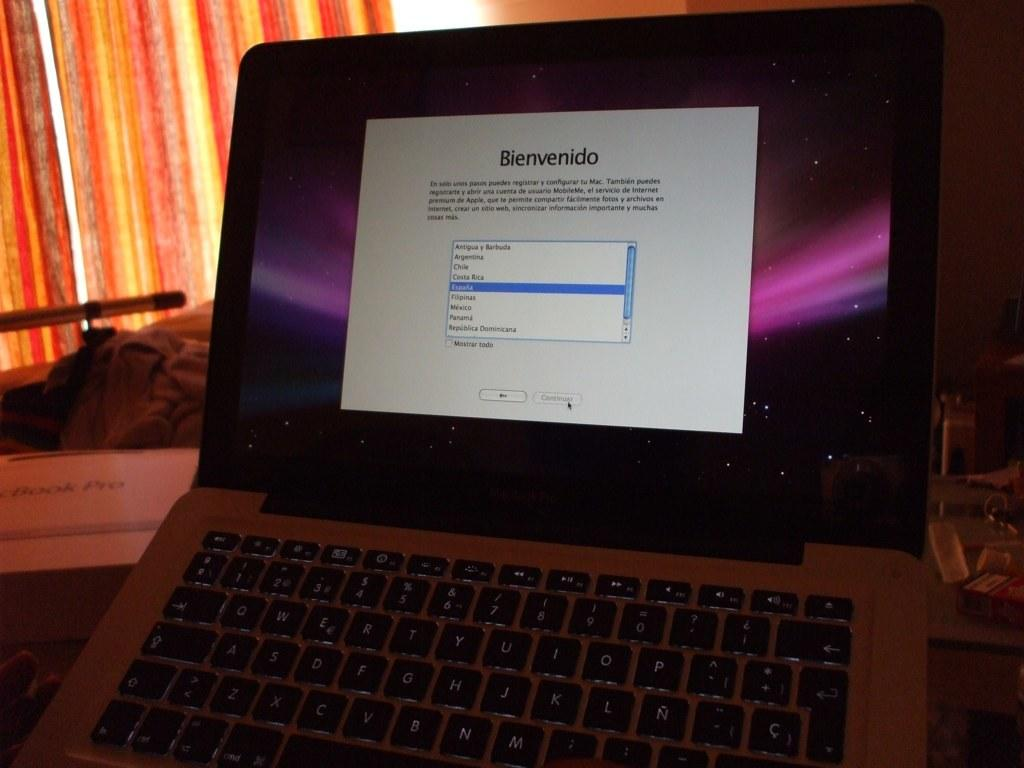<image>
Describe the image concisely. an open laptop with the word bienvendido on a white background. 